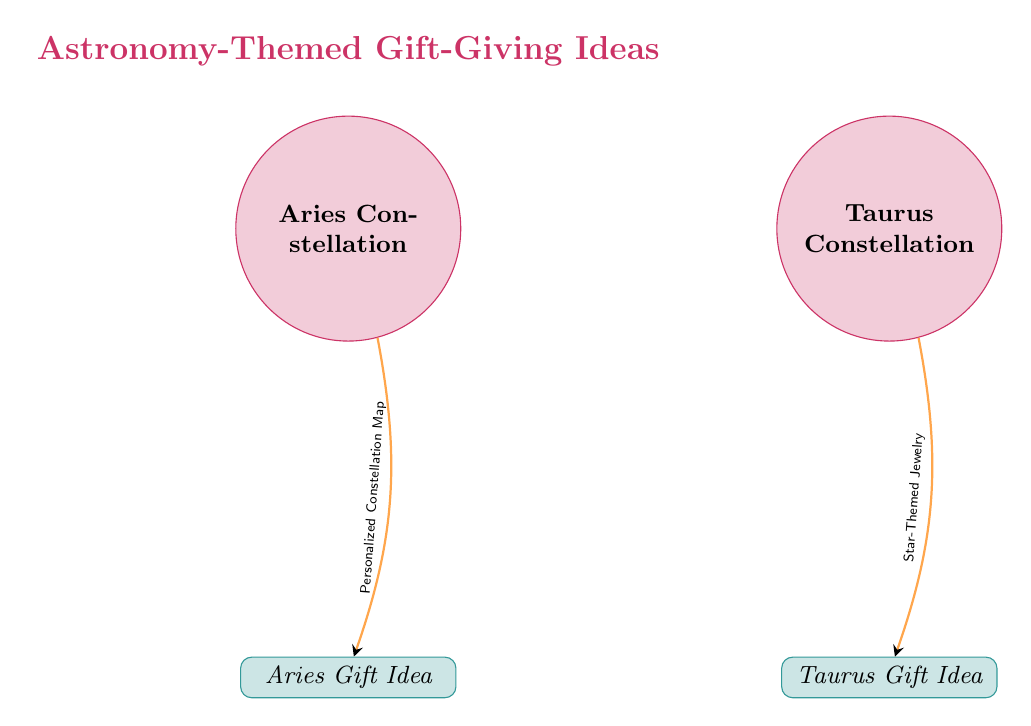What is the gift idea associated with Aries? The diagram shows that the gift idea associated with Aries is a "Personalized Constellation Map," which is connected directly to the Aries constellation.
Answer: Personalized Constellation Map How many constellations are illustrated in the diagram? There are two constellations illustrated in the diagram: Aries and Taurus. This can be counted directly from the nodes labeled as constellations.
Answer: 2 What type of gift is suggested for Taurus? The diagram indicates that the suggested gift for Taurus is "Star-Themed Jewelry,” which is located directly below the Taurus constellation node.
Answer: Star-Themed Jewelry Which constellation is directly connected to a gift and what is that gift? The Aries constellation is directly connected to the gift of a "Personalized Constellation Map," as indicated by the arrow pointing from the Aries node to its corresponding gift node.
Answer: Personalized Constellation Map What color is used for the Taurus constellation node? The Taurus constellation node is filled in a light purple shade, which can be identified by inspecting the color used for that specific node in the diagram.
Answer: purple!20 What is the relationship between the Aries constellation and its gift idea? The relationship is that the Aries constellation node is connected by an arrow to the gift idea of a "Personalized Constellation Map," indicating that this is the recommended gift for people born under this sign.
Answer: Personalized Constellation Map What color indicates the gift category in the diagram? The gifts in the diagram are indicated by a teal color scheme, as seen in the rectangle shape labeled for each gift idea.
Answer: teal!20 What theme do the gift ideas represent in the diagram? The theme of the gift ideas in the diagram is "Astronomy-Themed Gift-Giving Ideas," as stated at the top of the diagram.
Answer: Astronomy-Themed Gift-Giving Ideas 